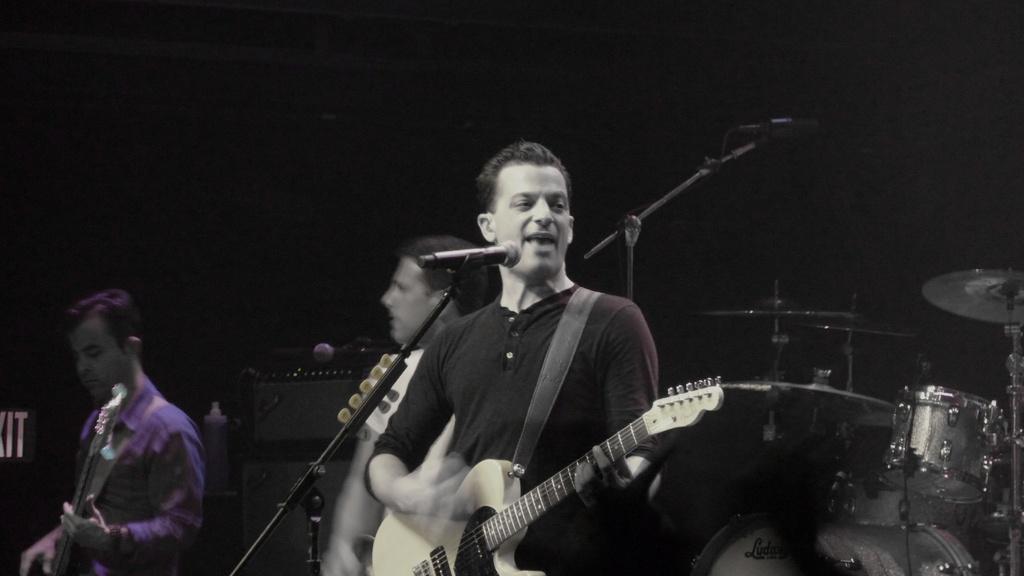How would you summarize this image in a sentence or two? These persons are standing and playing musical instruments and this person singing. There are microphones with stands. Behind these persons we can see musical instrument. 